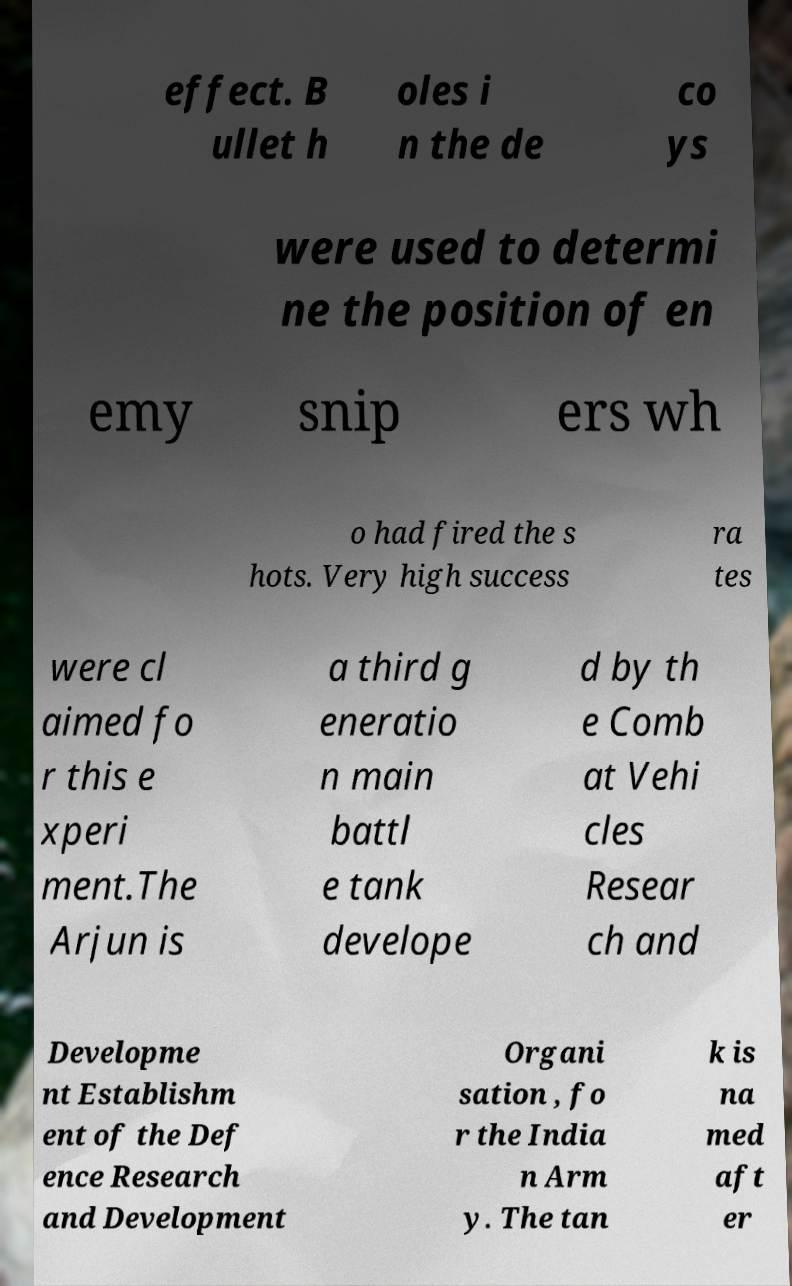Can you accurately transcribe the text from the provided image for me? effect. B ullet h oles i n the de co ys were used to determi ne the position of en emy snip ers wh o had fired the s hots. Very high success ra tes were cl aimed fo r this e xperi ment.The Arjun is a third g eneratio n main battl e tank develope d by th e Comb at Vehi cles Resear ch and Developme nt Establishm ent of the Def ence Research and Development Organi sation , fo r the India n Arm y. The tan k is na med aft er 